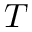Convert formula to latex. <formula><loc_0><loc_0><loc_500><loc_500>{ } T</formula> 